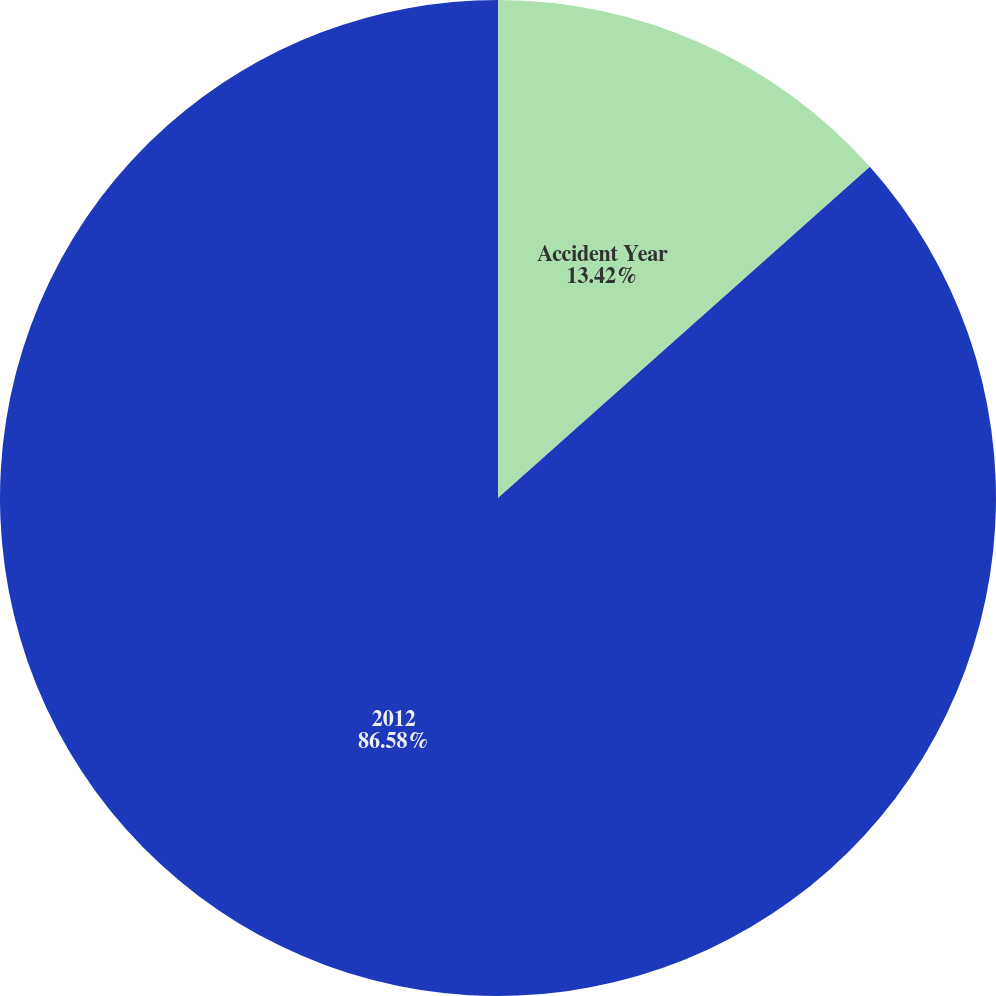Convert chart. <chart><loc_0><loc_0><loc_500><loc_500><pie_chart><fcel>Accident Year<fcel>2012<nl><fcel>13.42%<fcel>86.58%<nl></chart> 